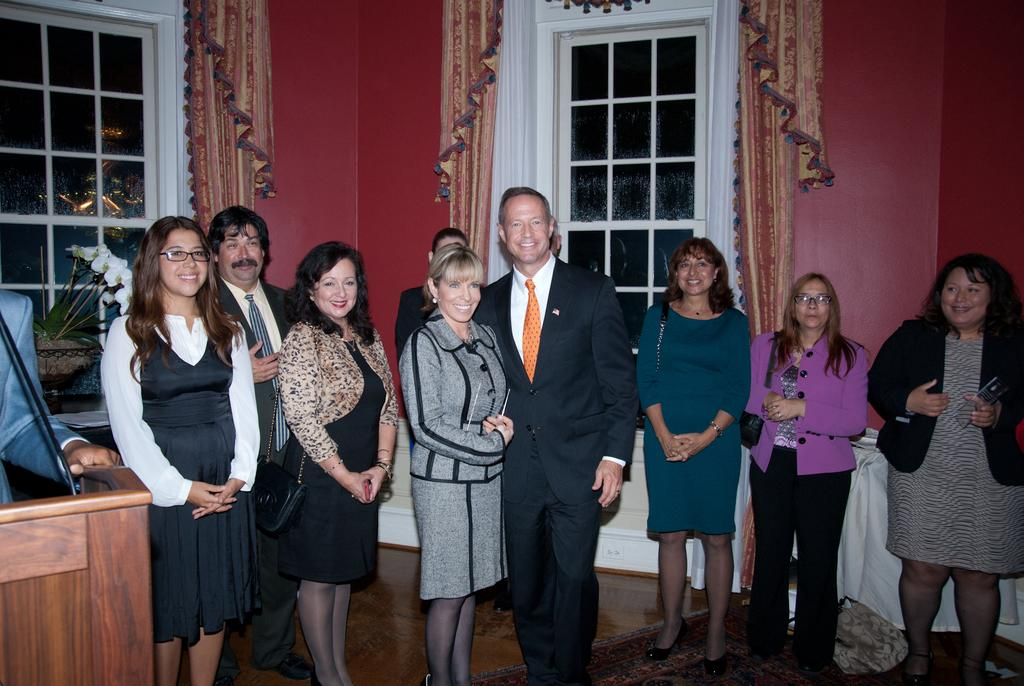What are the people in the image doing? The people in the image are standing and smiling. What are the two men wearing? The two men are wearing suits. Can you describe the person on the left side of the image? There is another person on the left side of the image, but their clothing or appearance is not specified in the facts. What architectural features can be seen in the image? Windows, curtains, and walls are visible in the image. What type of flesh can be seen on the person's finger in the image? There is no flesh or finger visible in the image; the people are standing and smiling, but their hands are not mentioned in the facts. 